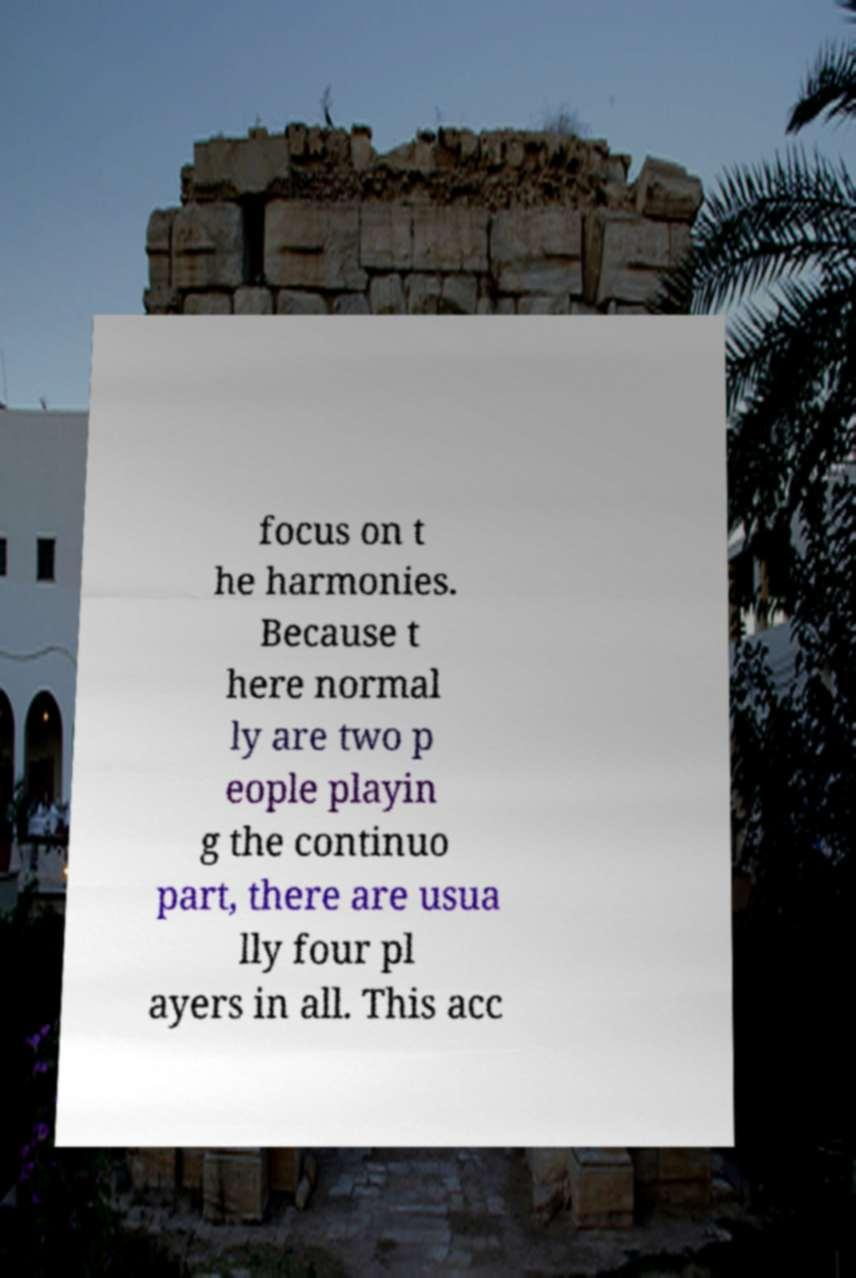For documentation purposes, I need the text within this image transcribed. Could you provide that? focus on t he harmonies. Because t here normal ly are two p eople playin g the continuo part, there are usua lly four pl ayers in all. This acc 